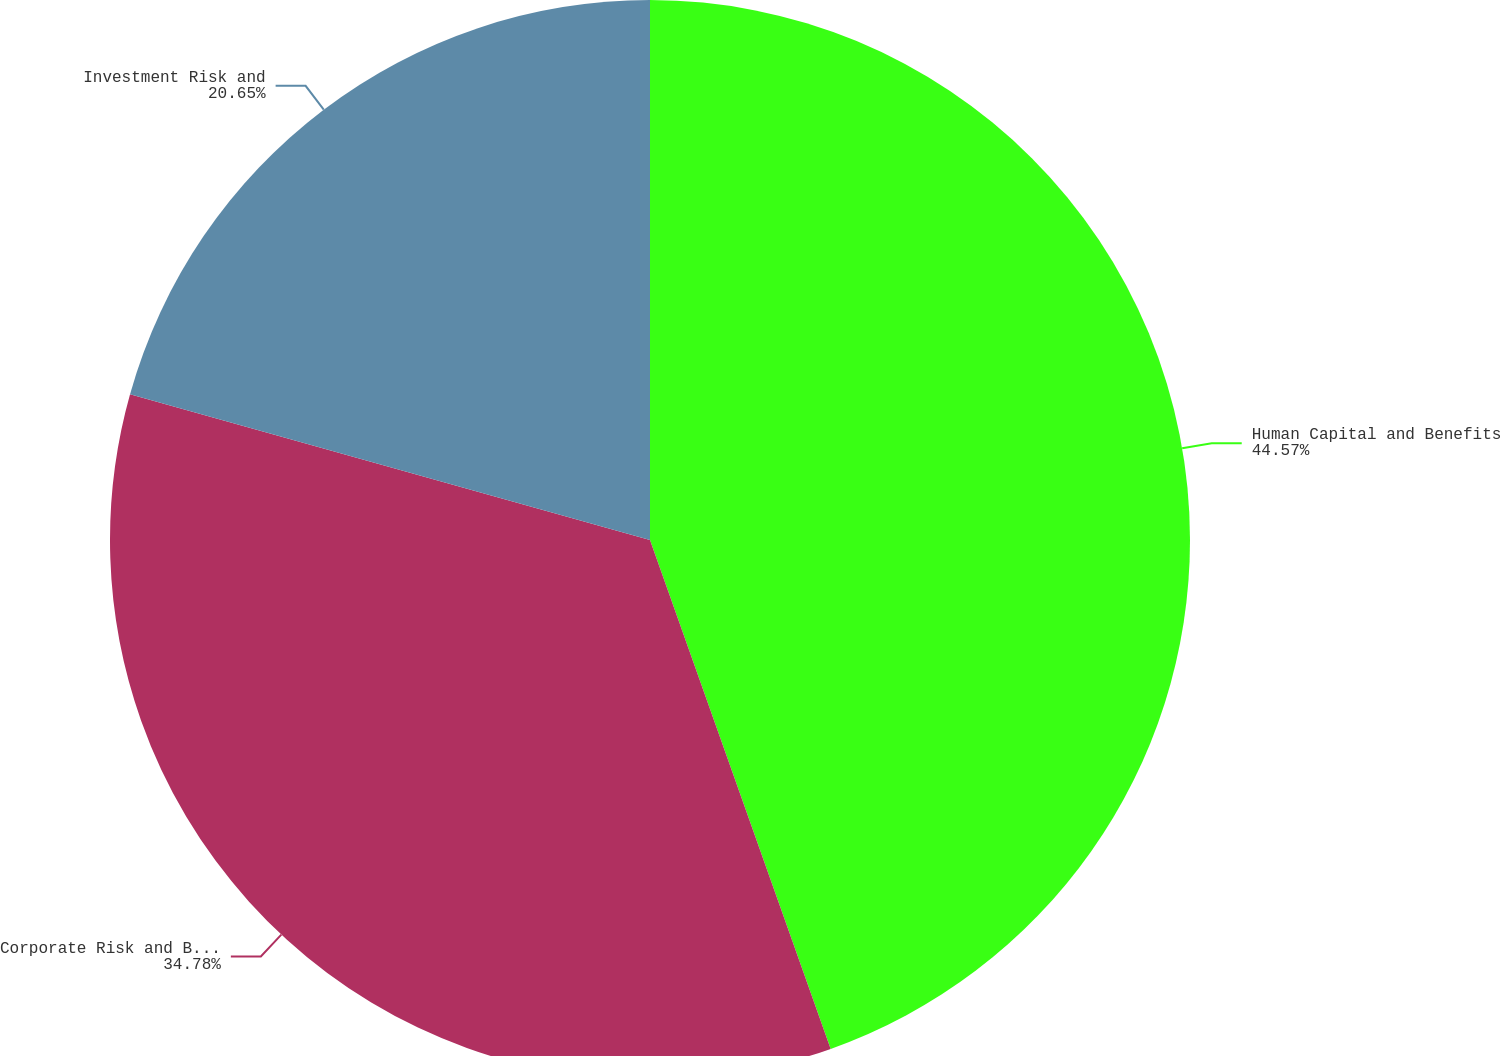Convert chart to OTSL. <chart><loc_0><loc_0><loc_500><loc_500><pie_chart><fcel>Human Capital and Benefits<fcel>Corporate Risk and Broking<fcel>Investment Risk and<nl><fcel>44.57%<fcel>34.78%<fcel>20.65%<nl></chart> 